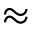<formula> <loc_0><loc_0><loc_500><loc_500>\approx</formula> 